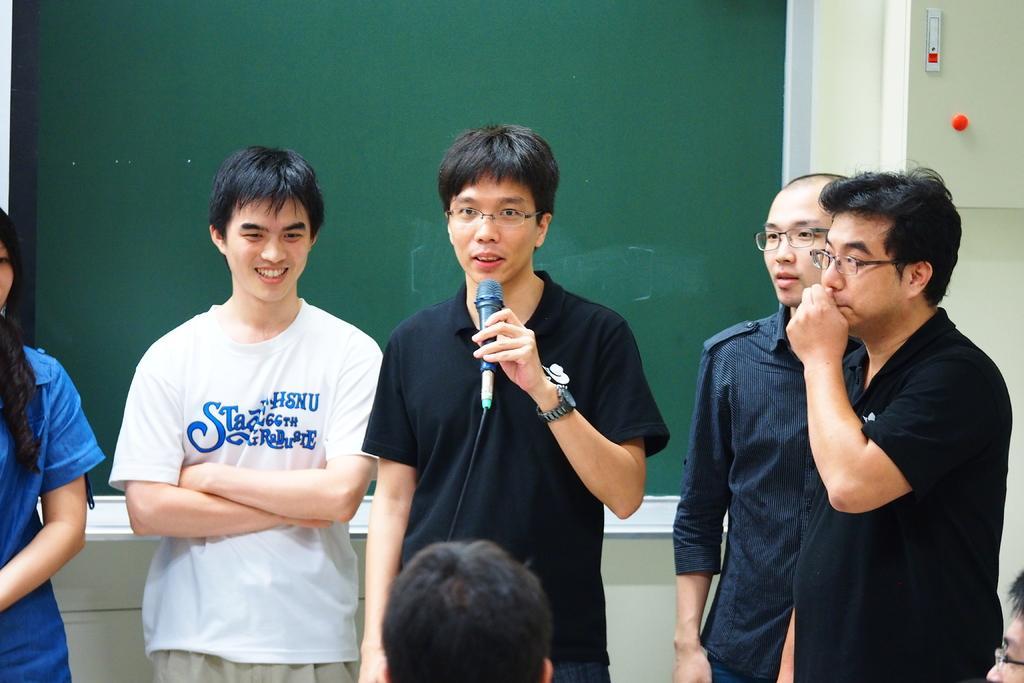Describe this image in one or two sentences. In this image I can see few people are standing and I can see the right four men are wearing specs. In the center I can see a man is holding a mic and behind him I can see a green colour board. On the bottom side of this image I can see head of a person. I can also see a box on the top right corner of this image. 